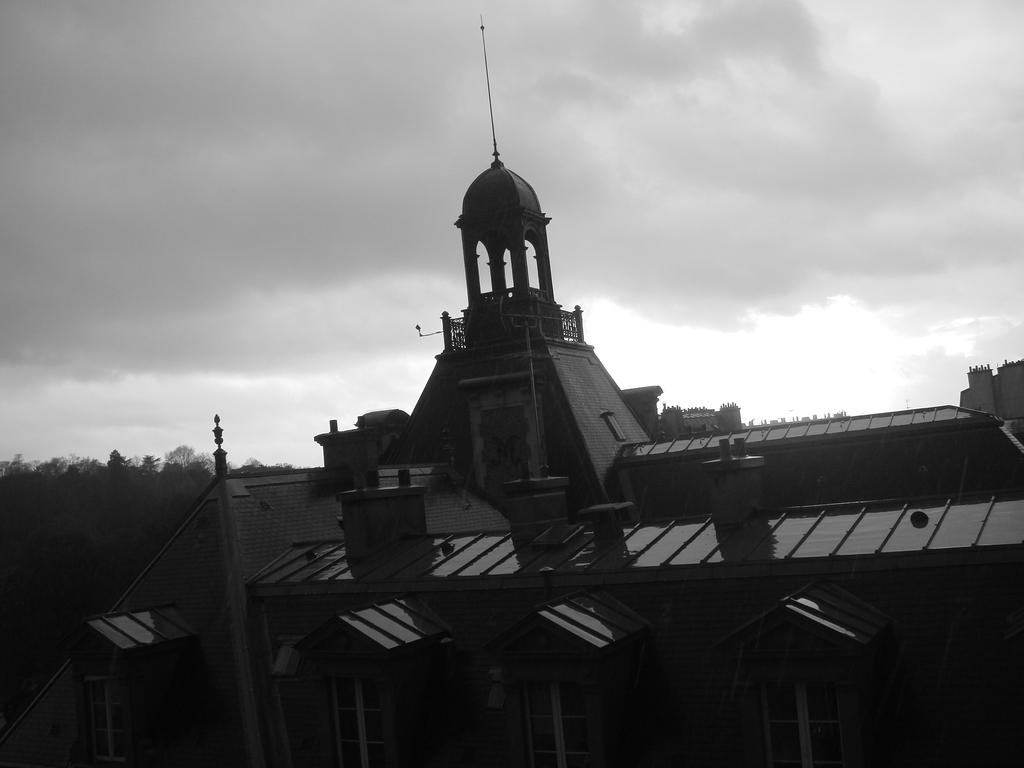What is the color scheme of the image? The image is black and white. What is the main subject in the image? There is a building in the image. What can be seen behind the building? There are trees behind the building. What is visible in the background of the image? The sky is visible in the background of the image, and there are clouds in the sky. How much does the baby weigh in the image? There is no baby present in the image, so it is not possible to determine the weight of a baby. 